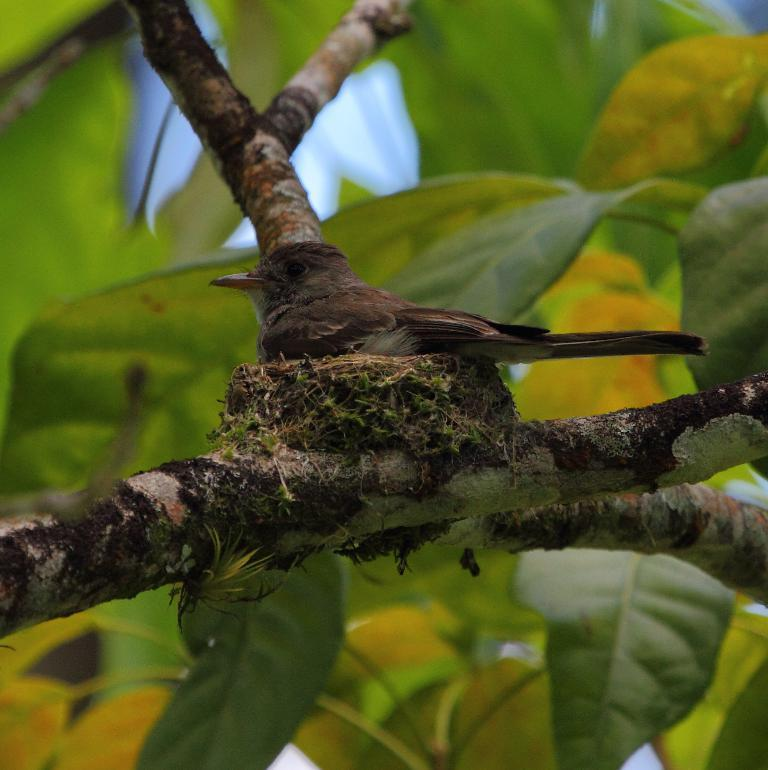What is the bird doing in the image? The bird is sitting on a nest in the image. Where is the nest located? The nest is on a branch of a tree. What can be seen in the background of the image? Leaves are visible in the background of the image. How many snails are visible on the branch of the tree in the image? There are no snails visible on the branch of the tree in the image. What decision did the bird make to choose this particular branch for its nest? The image does not provide information about the bird's decision-making process, so we cannot answer this question. 